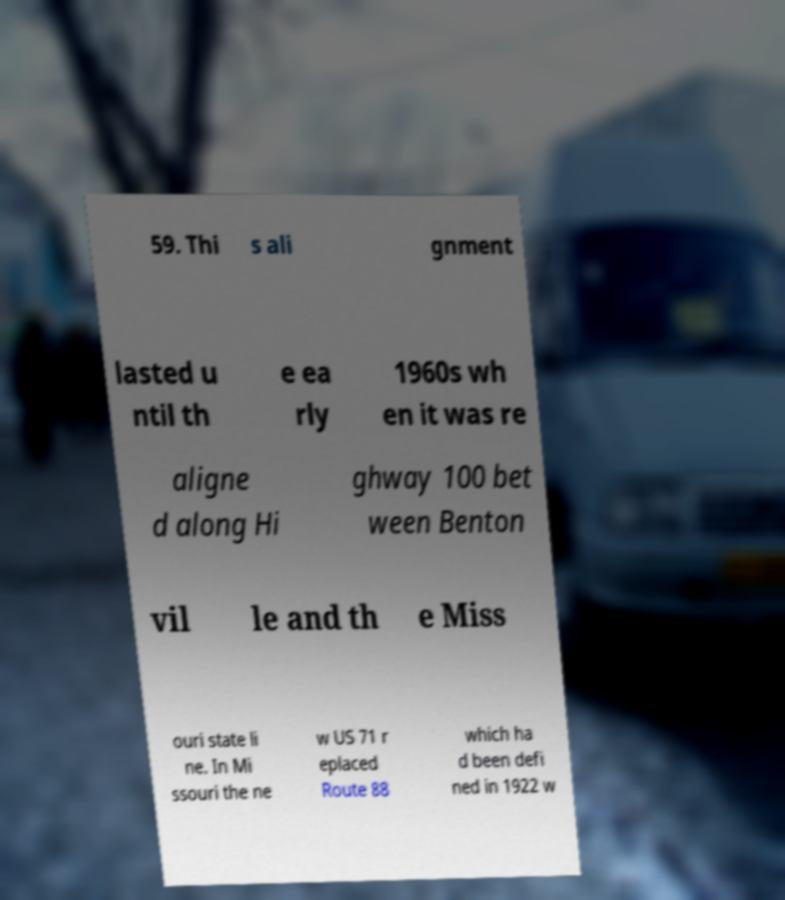There's text embedded in this image that I need extracted. Can you transcribe it verbatim? 59. Thi s ali gnment lasted u ntil th e ea rly 1960s wh en it was re aligne d along Hi ghway 100 bet ween Benton vil le and th e Miss ouri state li ne. In Mi ssouri the ne w US 71 r eplaced Route 88 which ha d been defi ned in 1922 w 